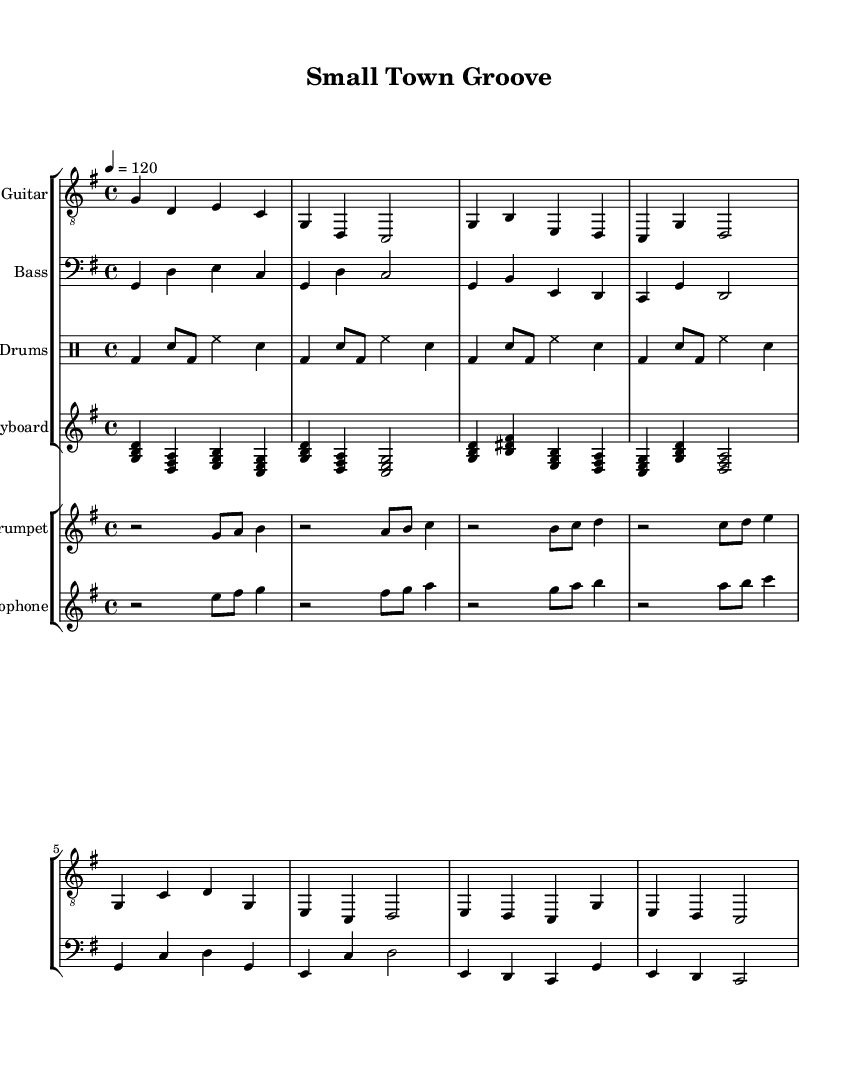What is the key signature of this music? The key signature is indicated at the beginning of the staff, and it shows one sharp. This corresponds to the key of G major.
Answer: G major What is the time signature of this piece? The time signature is shown as 4/4 at the beginning of the score, indicating four beats in each measure and the quarter note gets one beat.
Answer: 4/4 What is the tempo marking for this composition? The tempo marking is indicated as "4 = 120", meaning that the quarter note should be played at a speed of 120 beats per minute.
Answer: 120 How many instruments are included in the score? The score includes two staff groups: one for the rhythm section (Electric Guitar, Bass, Drums, and Keyboard) and another for the brass section (Trumpet and Saxophone). Counting all the instruments gives a total of six.
Answer: 6 What is the primary rhythmic feel suitable for this Funk piece? Funk music typically emphasizes a strong backbeat and syncopation. The drum part and the bass lines contribute to this rhythmic feel, making the music feel groovy and danceable.
Answer: Syncopation Which instrument plays the melody in this score? The melody in this composition is primarily carried by the Trumpet and Saxophone sections as indicated in their respective parts. These instruments often lead in funk compositions.
Answer: Trumpet and Saxophone What is the first note played by the Electric Guitar? The Electric Guitar begins its part with the note G, which is notated as the first note in the sequence.
Answer: G 